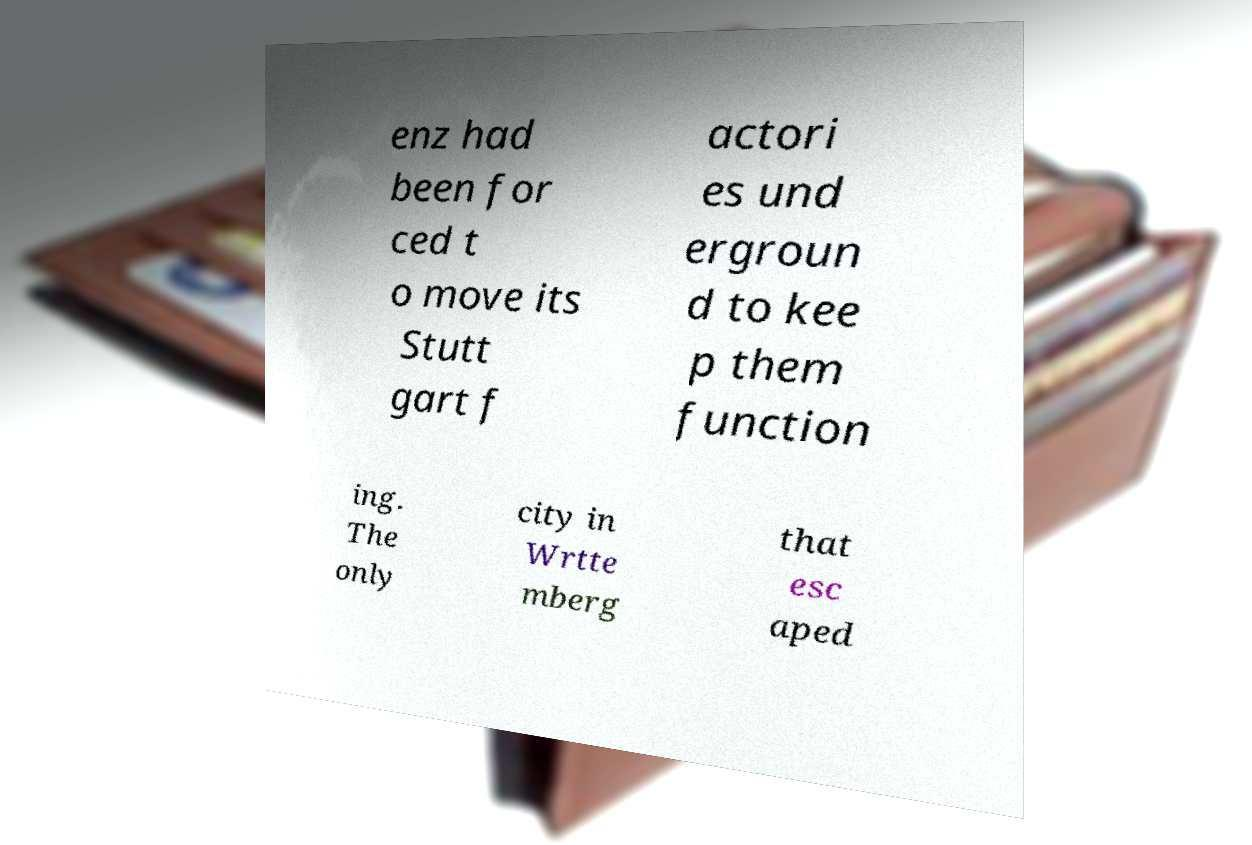Could you assist in decoding the text presented in this image and type it out clearly? enz had been for ced t o move its Stutt gart f actori es und ergroun d to kee p them function ing. The only city in Wrtte mberg that esc aped 